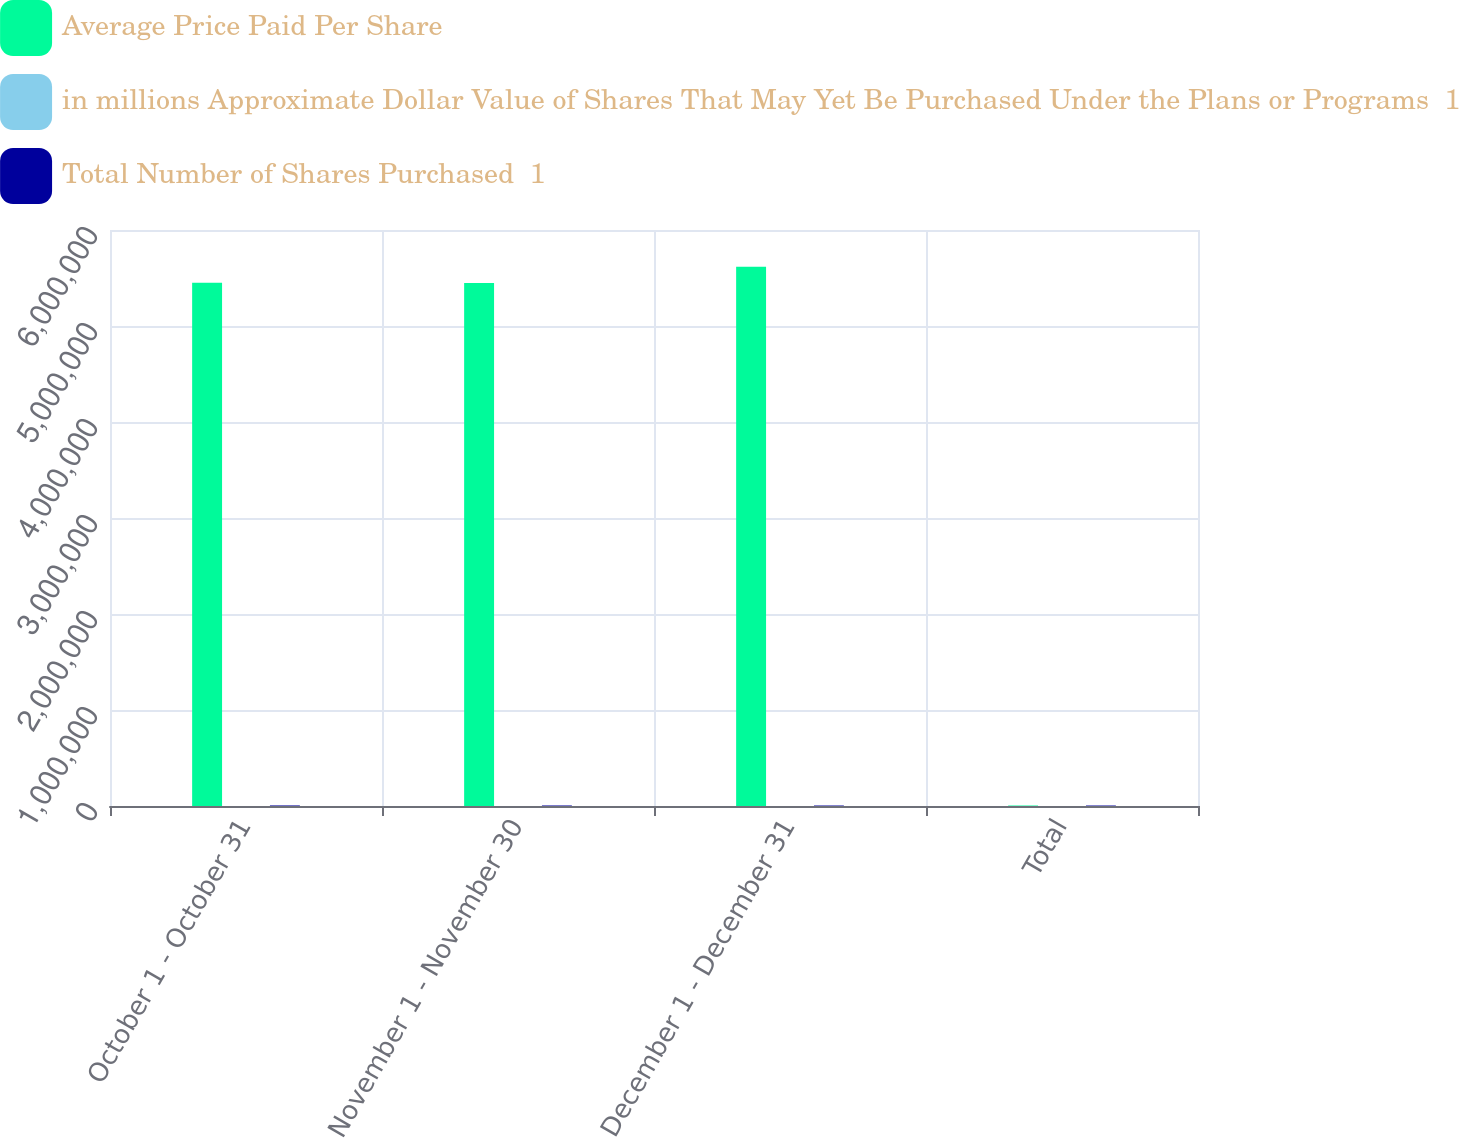Convert chart to OTSL. <chart><loc_0><loc_0><loc_500><loc_500><stacked_bar_chart><ecel><fcel>October 1 - October 31<fcel>November 1 - November 30<fcel>December 1 - December 31<fcel>Total<nl><fcel>Average Price Paid Per Share<fcel>5.4512e+06<fcel>5.4478e+06<fcel>5.618e+06<fcel>5055<nl><fcel>in millions Approximate Dollar Value of Shares That May Yet Be Purchased Under the Plans or Programs  1<fcel>62.17<fcel>61.39<fcel>60.96<fcel>61.5<nl><fcel>Total Number of Shares Purchased  1<fcel>5732<fcel>5397<fcel>5055<fcel>5055<nl></chart> 